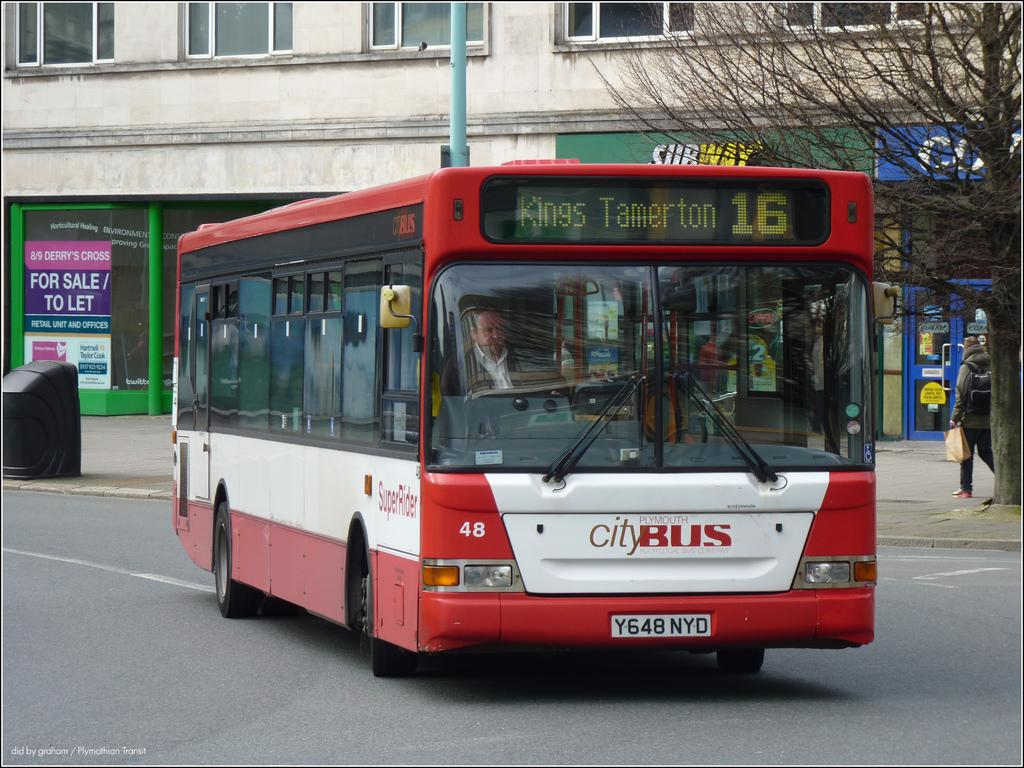Provide a one-sentence caption for the provided image. A red city bus is going to Kings Tamerton. 